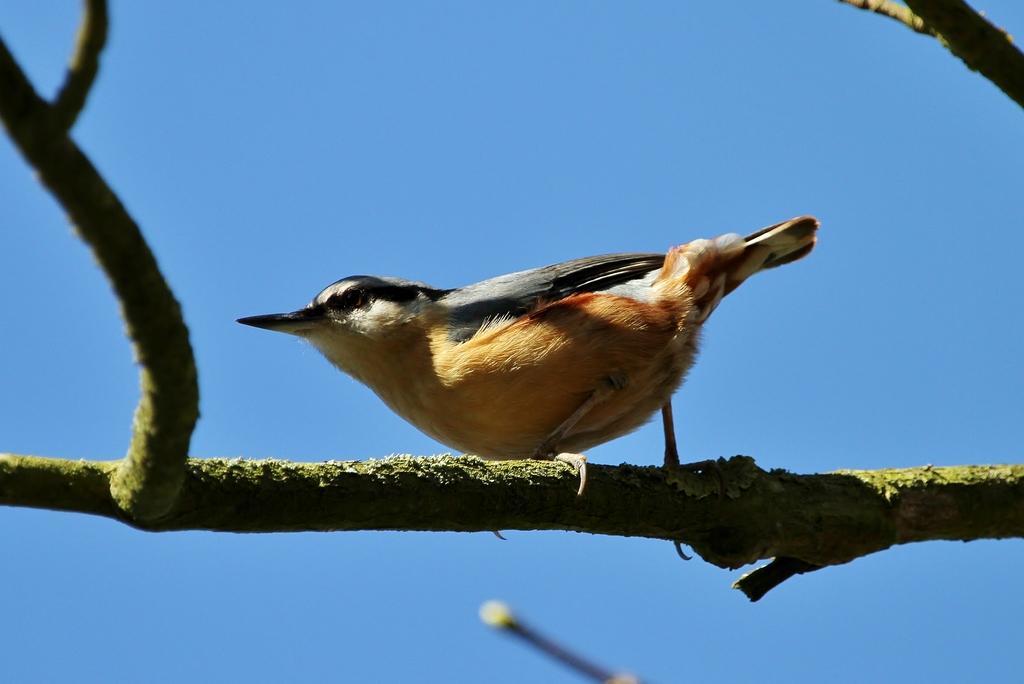Describe this image in one or two sentences. In this image in the center there is one bird on the tree, in the background there is sky. 